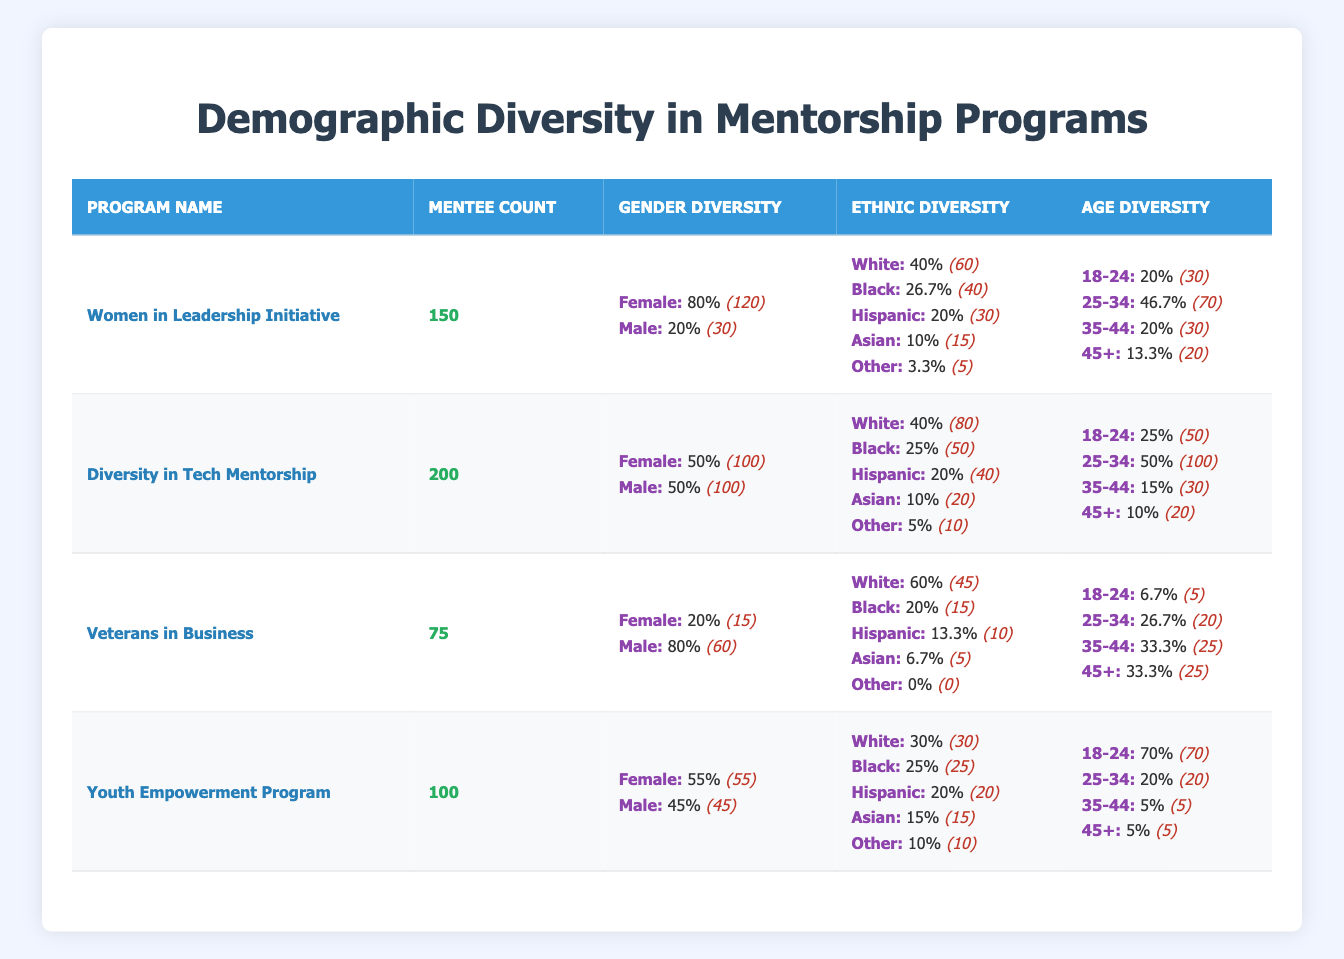What is the total number of mentees across all programs? To find the total number of mentees, we add the mentee counts of each program: 150 (Women in Leadership Initiative) + 200 (Diversity in Tech Mentorship) + 75 (Veterans in Business) + 100 (Youth Empowerment Program) = 525.
Answer: 525 What percentage of mentees in the Veterans in Business program are female? The Veterans in Business program has 15 female mentees out of a total of 75 mentees. To find the percentage, we calculate (15/75) * 100, which equals 20%.
Answer: 20% Which mentorship program has the highest percentage of Black mentees? To find this, we compare the percentages of Black mentees in each program. The percentages are: Women in Leadership Initiative (26.7%), Diversity in Tech Mentorship (25%), Veterans in Business (20%), and Youth Empowerment Program (25%). The Women in Leadership Initiative has the highest at 26.7%.
Answer: Women in Leadership Initiative Are there more male mentees than female mentees in the Youth Empowerment Program? The Youth Empowerment Program has 55 female mentees and 45 male mentees. Since 55 is greater than 45, there are more female mentees than male mentees.
Answer: No What is the average age group distribution for mentees in the Diversity in Tech Mentorship program? The age group distribution is: 18-24 (25%), 25-34 (50%), 35-44 (15%), and 45+ (10%). To find the average, we can take the percentage distribution as they represent the relative size, thus the average percentage of the age groups is 25% + 50% + 15% + 10% = 100%, and since they're a distribution, the average is simply the weighted means which is consistent with these percentages.
Answer: 100% In which age group do the majority of mentees in the Women in Leadership Initiative program belong? The age group distribution for the Women in Leadership Initiative program is as follows: 18-24 (20%), 25-34 (46.7%), 35-44 (20%), and 45+ (13.3%). The highest percentage is in the 25-34 age group at 46.7%.
Answer: 25-34 What is the combined percentage of White and Hispanic mentees in the Youth Empowerment Program? In the Youth Empowerment Program, the percentage of White mentees is 30% and Hispanic mentees is 20%. Adding these together gives us 30% + 20% = 50%.
Answer: 50% How does the gender distribution in the Diversity in Tech Mentorship program compare with the Women in Leadership Initiative? The Diversity in Tech Mentorship program has an equal distribution of gender (50% female, 50% male). In comparison, the Women in Leadership Initiative has 80% female and 20% male. Hence, the Diversity in Tech Mentorship is more balanced in gender representation compared to the Women in Leadership Initiative.
Answer: More balanced in Diversity in Tech Mentorship Which mentorship program has the fewest total mentees, and how many are there? By examining the total mentees for each program: Women in Leadership Initiative (150), Diversity in Tech Mentorship (200), Veterans in Business (75), and Youth Empowerment Program (100), the Veterans in Business program has the fewest mentees with 75.
Answer: Veterans in Business, 75 